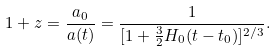<formula> <loc_0><loc_0><loc_500><loc_500>1 + z = \frac { a _ { 0 } } { a ( t ) } = \frac { 1 } { [ 1 + \frac { 3 } { 2 } H _ { 0 } ( t - t _ { 0 } ) ] ^ { 2 / 3 } } .</formula> 